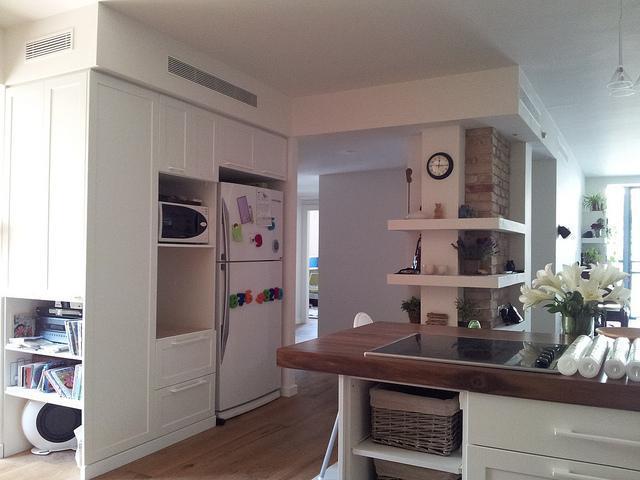How many potted plants are in the photo?
Give a very brief answer. 1. How many refrigerators are in the photo?
Give a very brief answer. 1. 